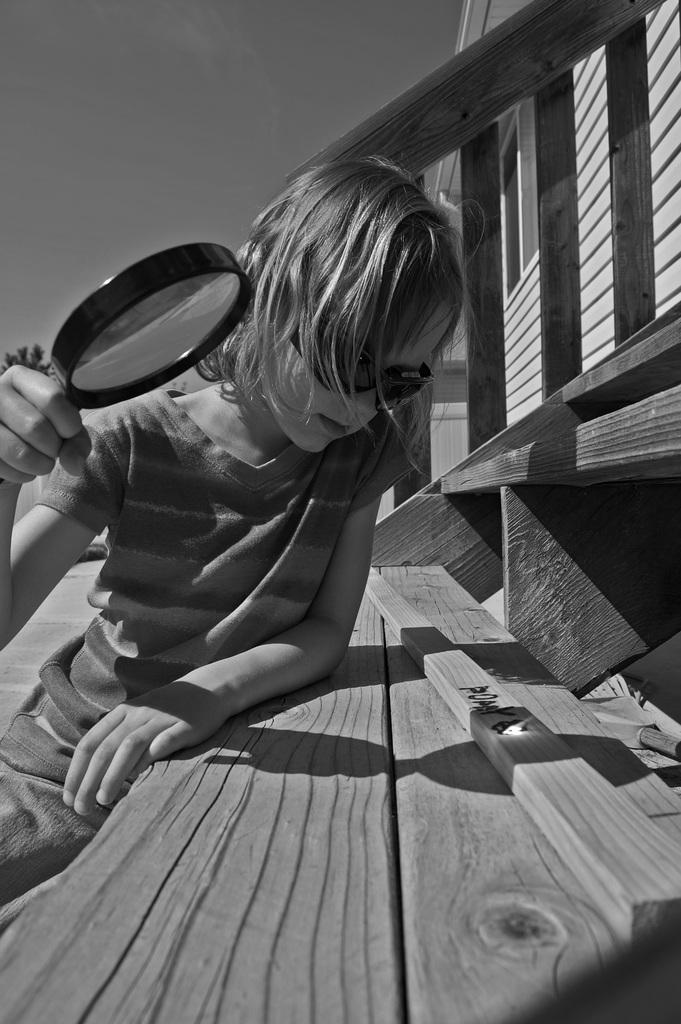What is the main subject of the picture? The main subject of the picture is a kid. What is the kid wearing that is visible in the image? The kid is wearing black color goggles. Where is the kid sitting in the image? The kid is sitting on wooden stairs. What object is the kid holding in the image? The kid is holding a magnifying glass. What type of structure can be seen on the right side of the picture? There is a wooden house on the right side of the picture. Where is the shelf located in the image? There is no shelf present in the image. Who is the partner of the kid in the image? There is no partner visible in the image; it only features the kid. 